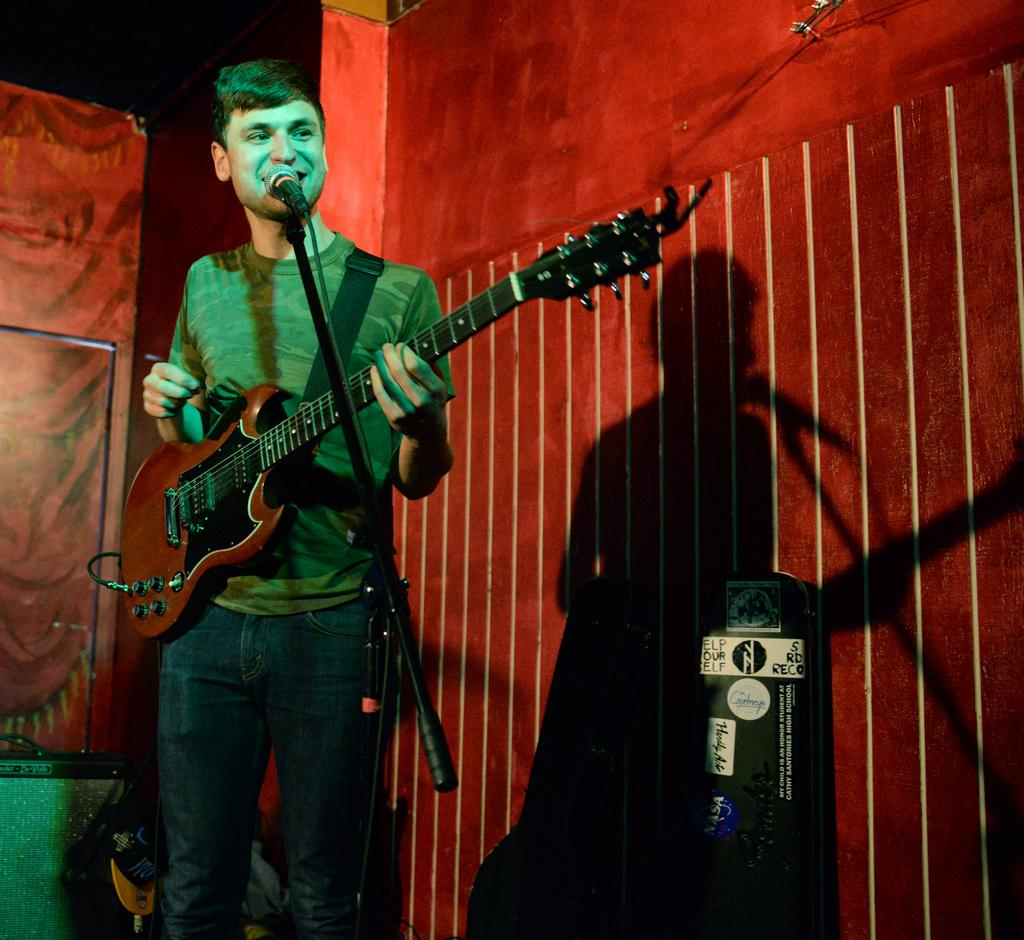What is the main subject of the image? The main subject of the image is a man. What is the man doing in the image? The man is standing and holding a guitar. Is the man performing any activity related to the guitar? Yes, the man is singing with the help of a microphone. What type of silk fabric is being used as a backdrop for the school performance in the image? There is no school performance or silk fabric present in the image. 